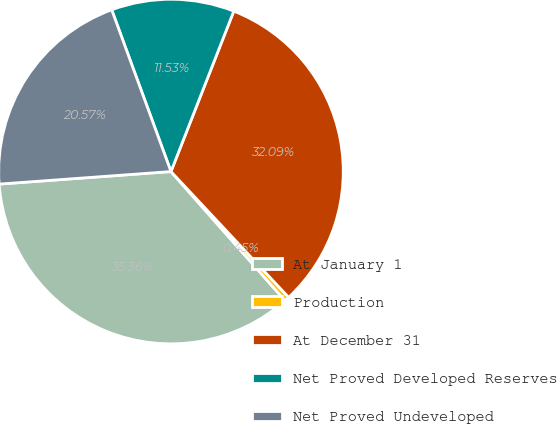Convert chart. <chart><loc_0><loc_0><loc_500><loc_500><pie_chart><fcel>At January 1<fcel>Production<fcel>At December 31<fcel>Net Proved Developed Reserves<fcel>Net Proved Undeveloped<nl><fcel>35.36%<fcel>0.45%<fcel>32.09%<fcel>11.53%<fcel>20.57%<nl></chart> 